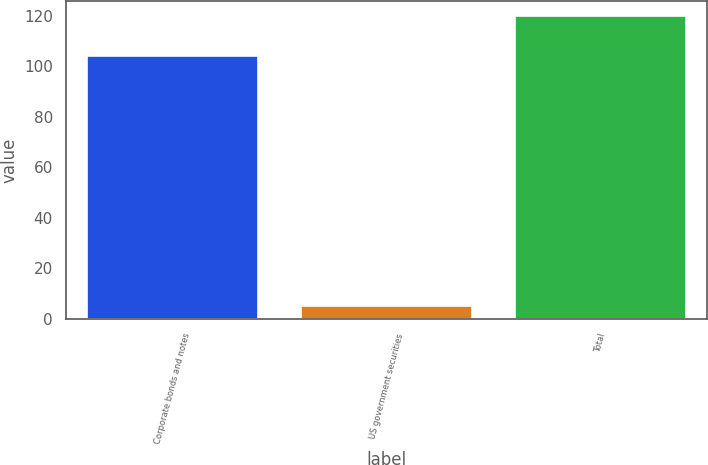Convert chart. <chart><loc_0><loc_0><loc_500><loc_500><bar_chart><fcel>Corporate bonds and notes<fcel>US government securities<fcel>Total<nl><fcel>104<fcel>5<fcel>120<nl></chart> 